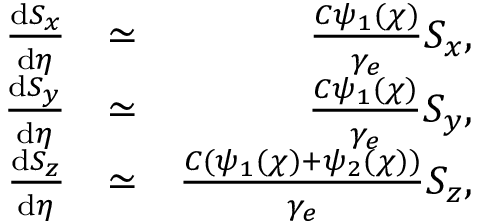Convert formula to latex. <formula><loc_0><loc_0><loc_500><loc_500>\begin{array} { r l r } { \frac { d { S _ { x } } } { d \eta } } & { \simeq } & { \frac { C \psi _ { 1 } ( \chi ) } { \gamma _ { e } } S _ { x } , } \\ { \frac { d { S _ { y } } } { d \eta } } & { \simeq } & { \frac { C \psi _ { 1 } ( \chi ) } { \gamma _ { e } } S _ { y } , } \\ { \frac { d { S _ { z } } } { d \eta } } & { \simeq } & { \frac { C ( \psi _ { 1 } ( \chi ) + \psi _ { 2 } ( \chi ) ) } { \gamma _ { e } } S _ { z } , } \end{array}</formula> 